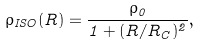Convert formula to latex. <formula><loc_0><loc_0><loc_500><loc_500>\rho _ { I S O } ( R ) = \frac { \rho _ { 0 } } { 1 + ( { { R } / { R _ { C } } } ) ^ { 2 } } ,</formula> 